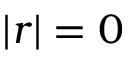Convert formula to latex. <formula><loc_0><loc_0><loc_500><loc_500>| r | = 0</formula> 